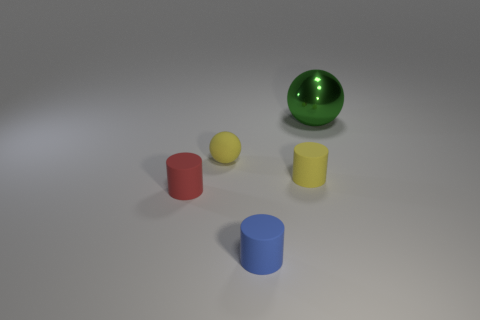Add 2 tiny brown metallic cubes. How many objects exist? 7 Subtract all balls. How many objects are left? 3 Add 4 small yellow balls. How many small yellow balls exist? 5 Subtract 0 red spheres. How many objects are left? 5 Subtract all gray metal blocks. Subtract all small matte objects. How many objects are left? 1 Add 4 small yellow cylinders. How many small yellow cylinders are left? 5 